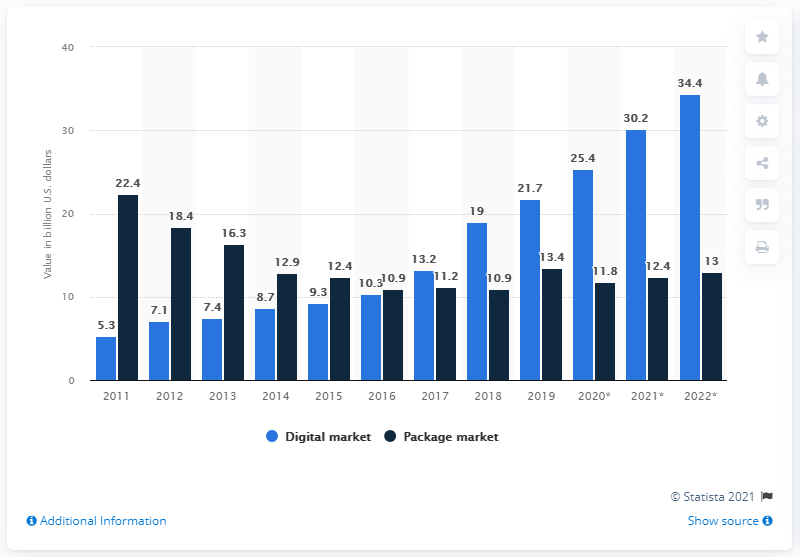Point out several critical features in this image. In 2019, packaged sales generated revenues of approximately 13.4 U.S. dollars. 